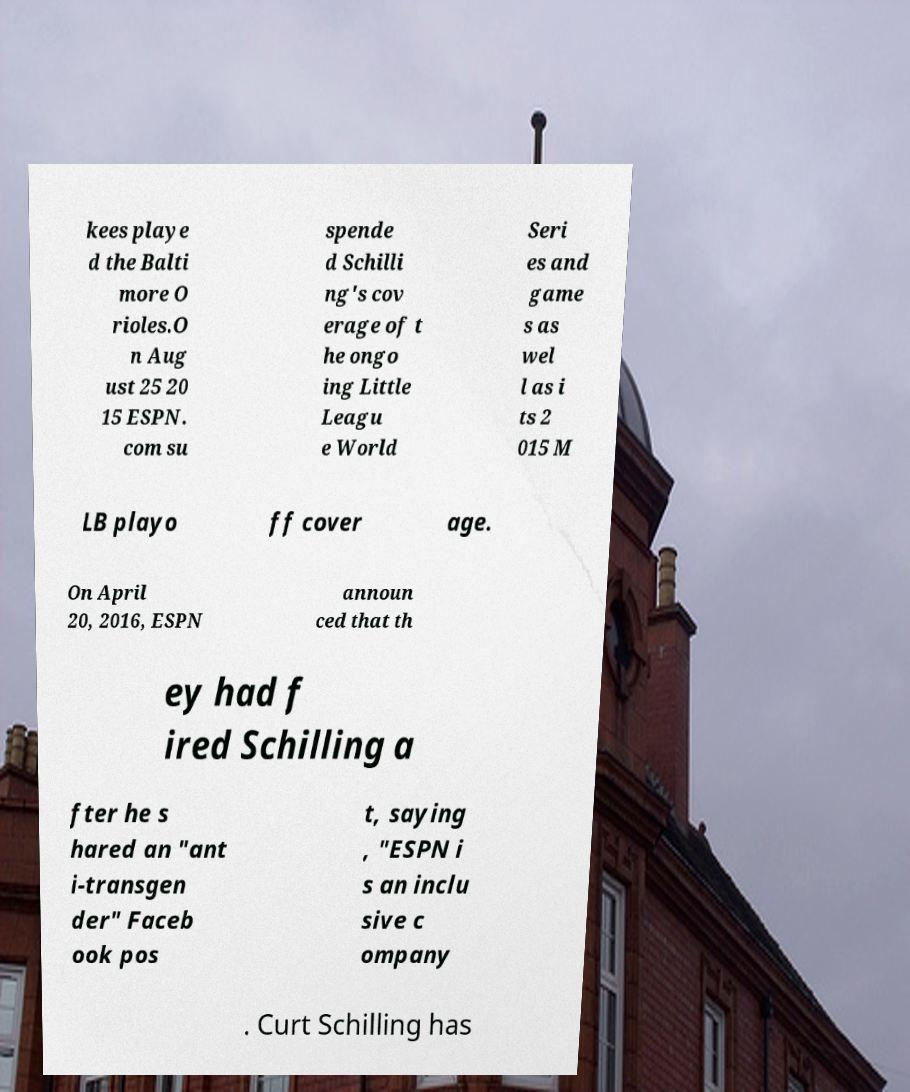Please identify and transcribe the text found in this image. kees playe d the Balti more O rioles.O n Aug ust 25 20 15 ESPN. com su spende d Schilli ng's cov erage of t he ongo ing Little Leagu e World Seri es and game s as wel l as i ts 2 015 M LB playo ff cover age. On April 20, 2016, ESPN announ ced that th ey had f ired Schilling a fter he s hared an "ant i-transgen der" Faceb ook pos t, saying , "ESPN i s an inclu sive c ompany . Curt Schilling has 